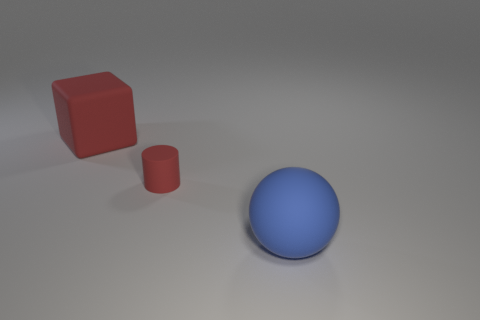Add 2 large cyan objects. How many objects exist? 5 Subtract all balls. How many objects are left? 2 Subtract 0 green cylinders. How many objects are left? 3 Subtract all purple cylinders. Subtract all big spheres. How many objects are left? 2 Add 2 tiny things. How many tiny things are left? 3 Add 1 red matte cylinders. How many red matte cylinders exist? 2 